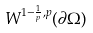Convert formula to latex. <formula><loc_0><loc_0><loc_500><loc_500>W ^ { 1 - \frac { 1 } { p } , p } ( \partial \Omega )</formula> 